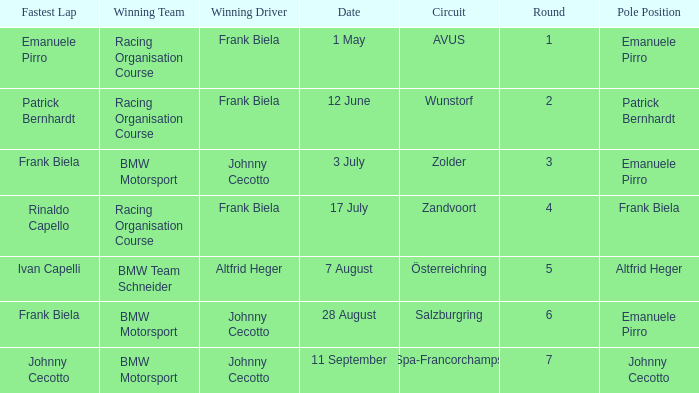Who was the winning team on the circuit Zolder? BMW Motorsport. 